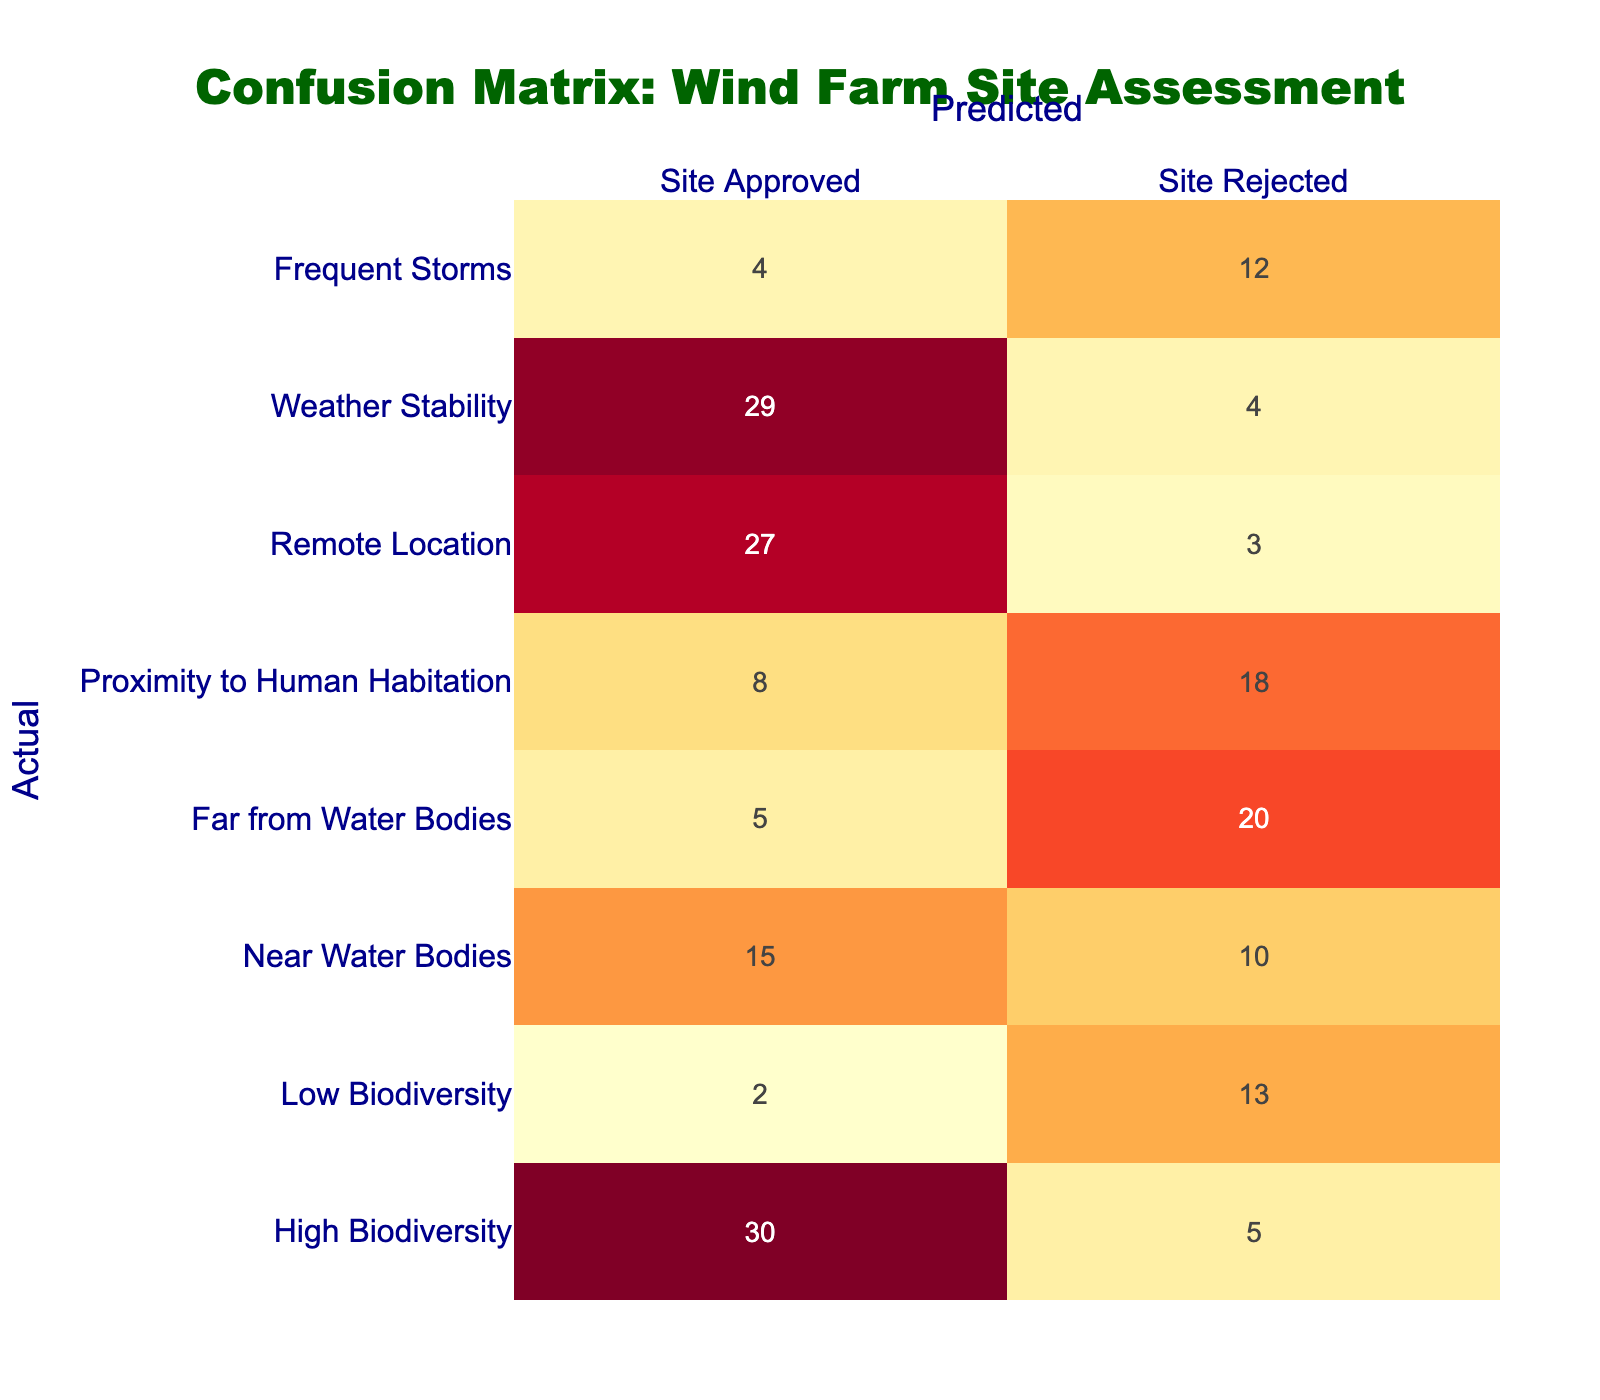What is the total number of sites classified as "Site Approved" for "High Biodiversity"? There are 30 sites classified as "Site Approved" under "High Biodiversity". This value can be found directly in the confusion matrix.
Answer: 30 What is the number of sites that are "Far from Water Bodies" and classified as "Site Approved"? The number of sites that are "Far from Water Bodies" and classified as "Site Approved" is 5, as indicated in the respective table cell.
Answer: 5 How many total sites were assessed that are "Near Water Bodies"? To find the total, we add the values from both classifications for "Near Water Bodies": 15 (Site Approved) + 10 (Site Rejected) = 25.
Answer: 25 Is there a site classification for "Frequent Storms" that has more "Site Approved" than "Site Rejected"? No, for "Frequent Storms," there are only 4 "Site Approved" while there are 12 "Site Rejected", indicating fewer approvals.
Answer: No What is the total number of sites for "Weather Stability"? The total number of sites for "Weather Stability" is calculated by adding the values: 29 (Site Approved) + 4 (Site Rejected) = 33.
Answer: 33 How many times is a site with "Remote Location" more likely to be approved compared to a "Site Rejected"? For "Remote Location," there are 27 "Site Approved" and 3 "Site Rejected". To find how many times it is more likely to be approved, we divide: 27 / 3 = 9.
Answer: 9 What is the percentage of sites classified as "Site Rejected" for "Low Biodiversity"? The total sites classified under "Low Biodiversity" are 2 (Site Approved) + 13 (Site Rejected) = 15. The percentage for "Site Rejected" is (13/15) * 100 = 86.67%.
Answer: 86.67% If you combine the total number of sites classified as "Near Water Bodies" and "Frequent Storms" that were approved, what is that total? To find the total, we add the approved sites: 15 (Near Water Bodies) + 4 (Frequent Storms) = 19.
Answer: 19 